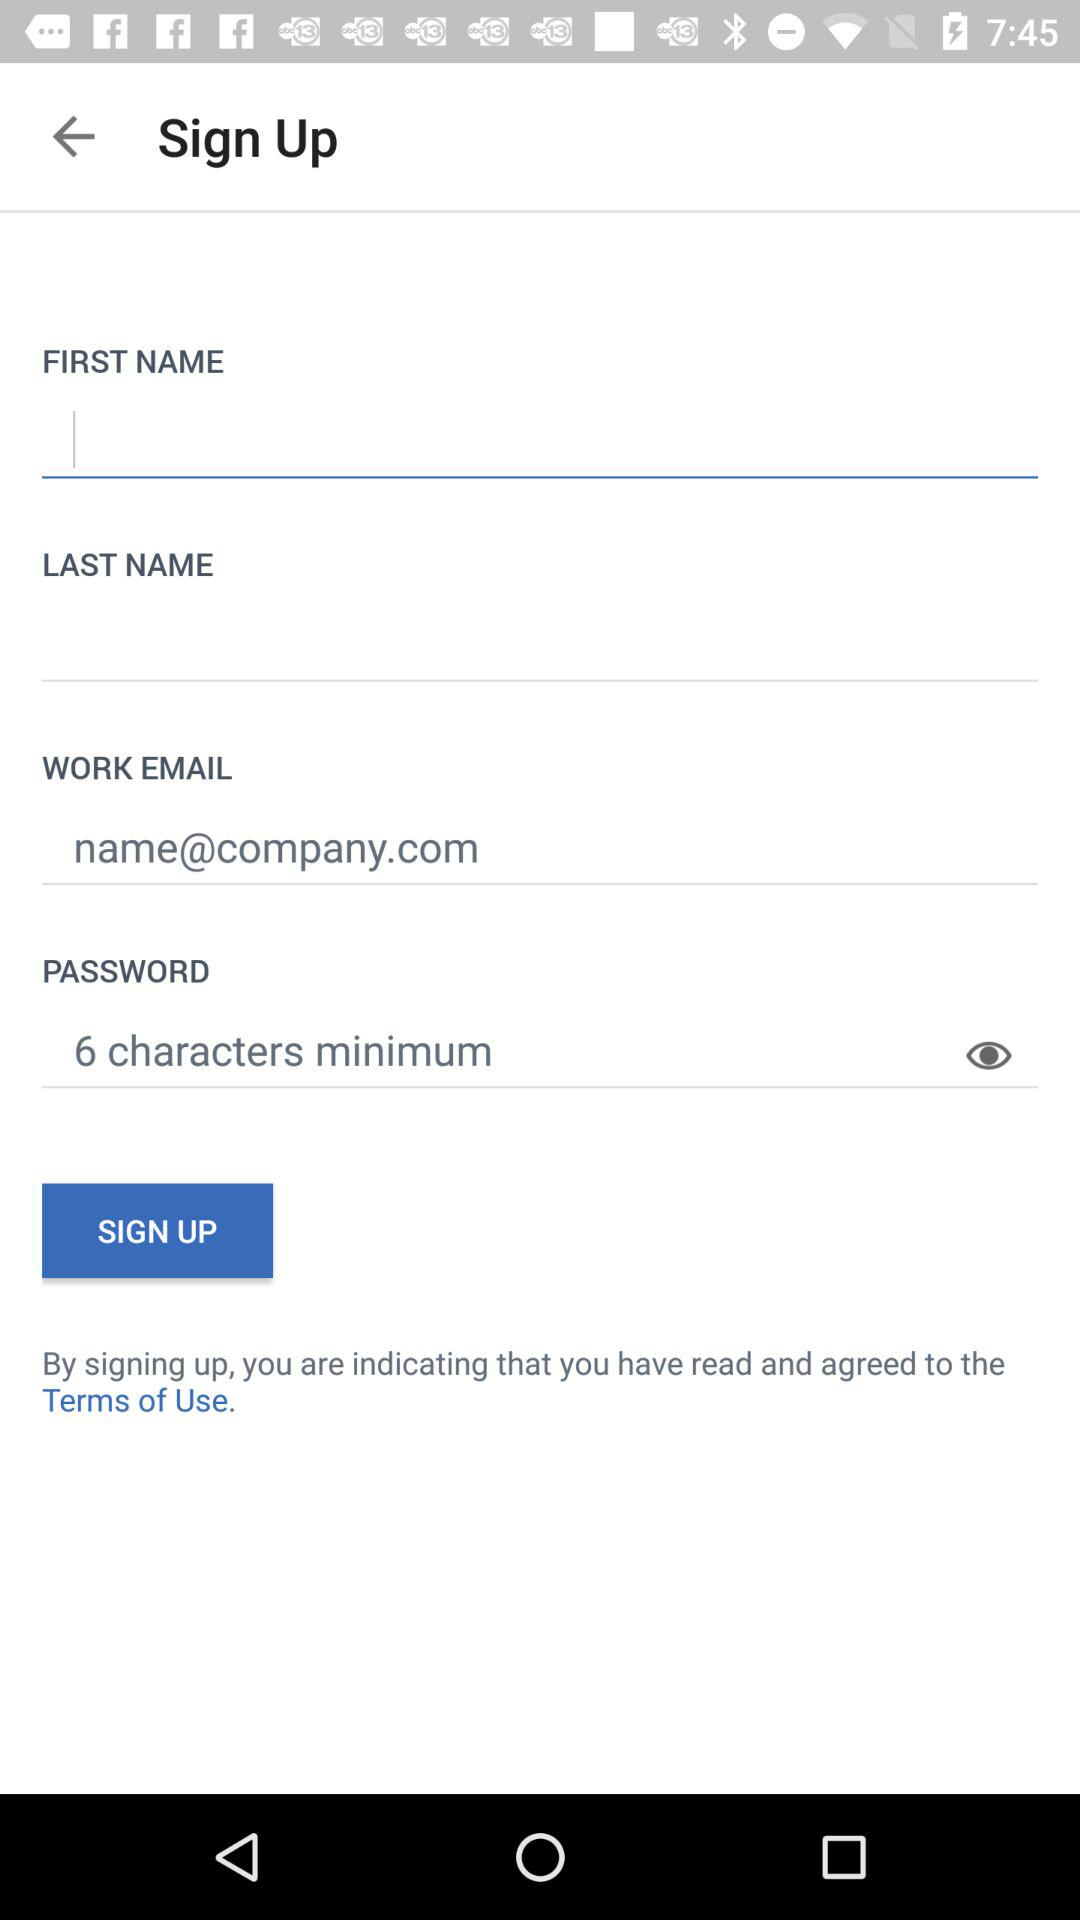What is the minimum limit of the password? The minimum limit of the password is 6 characters. 